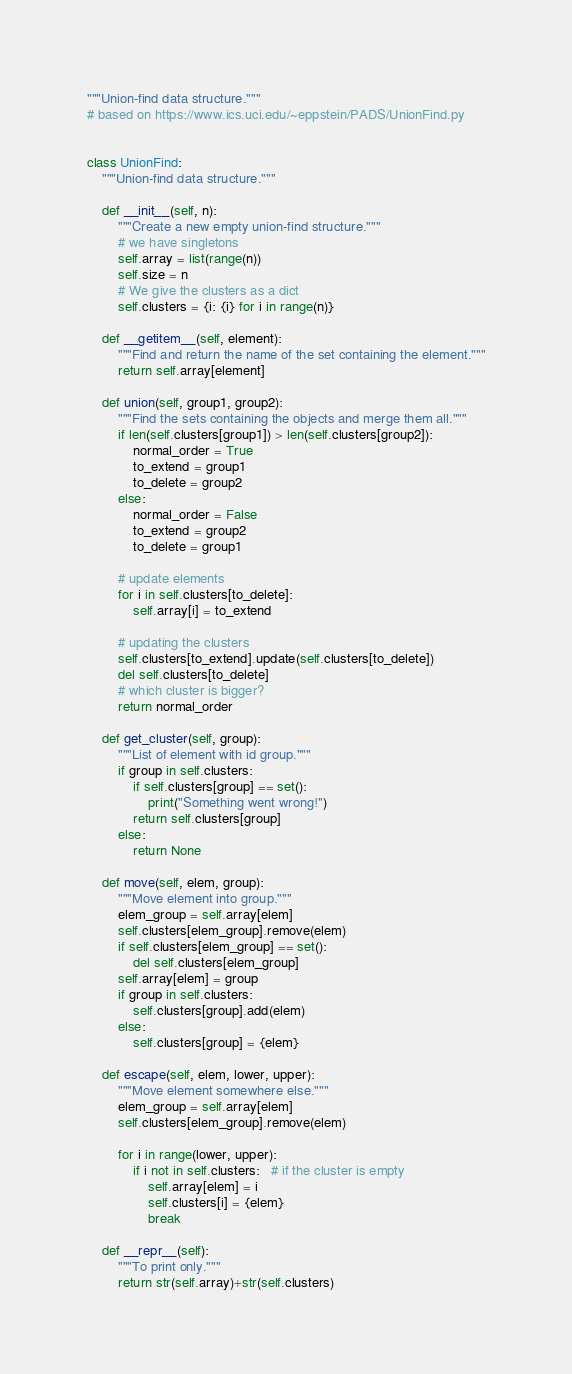Convert code to text. <code><loc_0><loc_0><loc_500><loc_500><_Python_>"""Union-find data structure."""
# based on https://www.ics.uci.edu/~eppstein/PADS/UnionFind.py


class UnionFind:
    """Union-find data structure."""

    def __init__(self, n):
        """Create a new empty union-find structure."""
        # we have singletons
        self.array = list(range(n))
        self.size = n
        # We give the clusters as a dict
        self.clusters = {i: {i} for i in range(n)}

    def __getitem__(self, element):
        """Find and return the name of the set containing the element."""
        return self.array[element]

    def union(self, group1, group2):
        """Find the sets containing the objects and merge them all."""
        if len(self.clusters[group1]) > len(self.clusters[group2]):
            normal_order = True
            to_extend = group1
            to_delete = group2
        else:
            normal_order = False
            to_extend = group2
            to_delete = group1

        # update elements
        for i in self.clusters[to_delete]:
            self.array[i] = to_extend

        # updating the clusters
        self.clusters[to_extend].update(self.clusters[to_delete])
        del self.clusters[to_delete]
        # which cluster is bigger?
        return normal_order

    def get_cluster(self, group):
        """List of element with id group."""
        if group in self.clusters:
            if self.clusters[group] == set():
                print("Something went wrong!")
            return self.clusters[group]
        else:
            return None

    def move(self, elem, group):
        """Move element into group."""
        elem_group = self.array[elem]
        self.clusters[elem_group].remove(elem)
        if self.clusters[elem_group] == set():
            del self.clusters[elem_group]
        self.array[elem] = group
        if group in self.clusters:
            self.clusters[group].add(elem)
        else:
            self.clusters[group] = {elem}

    def escape(self, elem, lower, upper):
        """Move element somewhere else."""
        elem_group = self.array[elem]
        self.clusters[elem_group].remove(elem)

        for i in range(lower, upper):
            if i not in self.clusters:   # if the cluster is empty
                self.array[elem] = i
                self.clusters[i] = {elem}
                break

    def __repr__(self):
        """To print only."""
        return str(self.array)+str(self.clusters)
</code> 